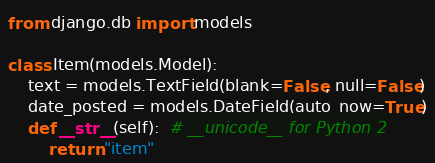<code> <loc_0><loc_0><loc_500><loc_500><_Python_>from django.db import models

class Item(models.Model):
    text = models.TextField(blank=False, null=False)
    date_posted = models.DateField(auto_now=True)
    def __str__(self):  # __unicode__ for Python 2
        return "item"</code> 